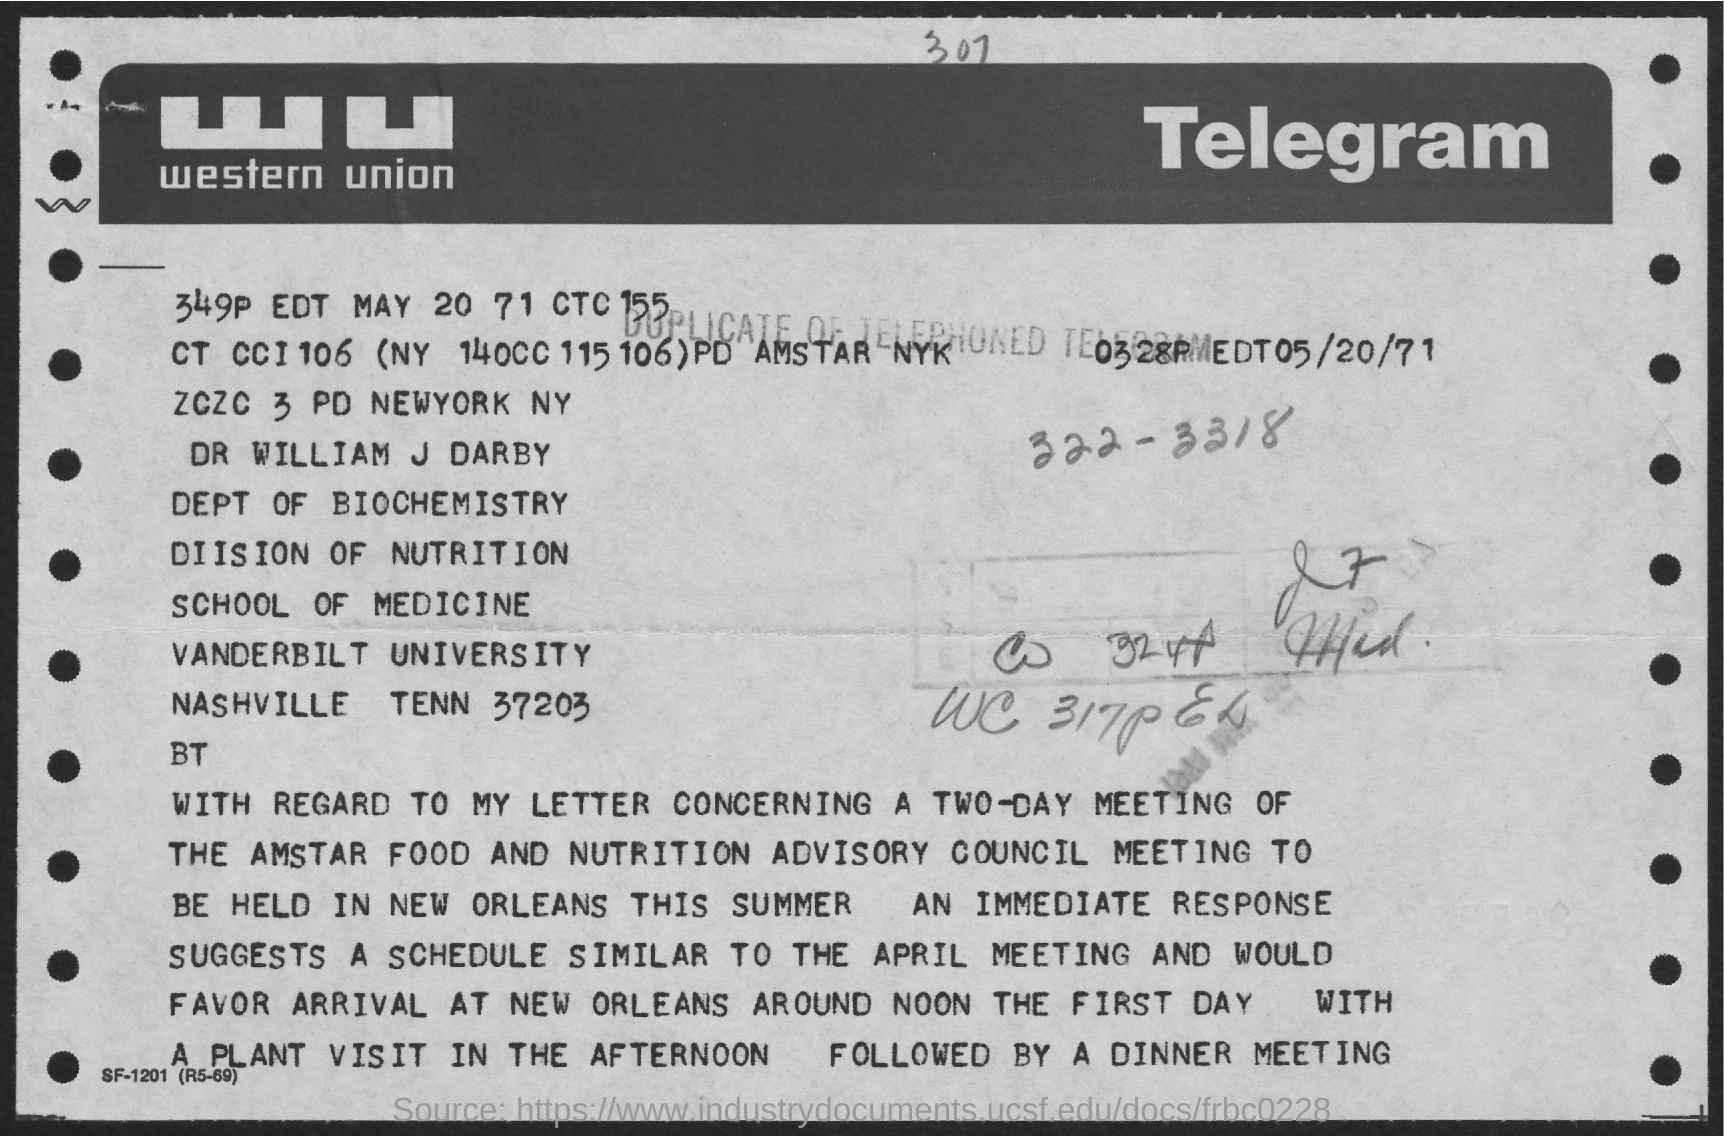Draw attention to some important aspects in this diagram. This letter is written to Dr. William J. Darby. The name of the university is Vanderbilt University. 